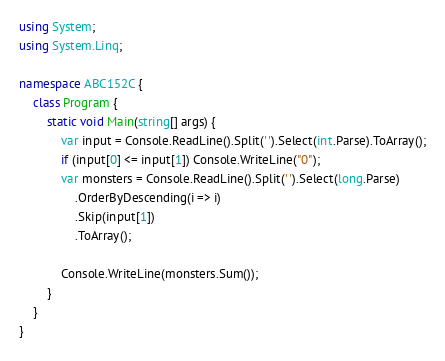<code> <loc_0><loc_0><loc_500><loc_500><_C#_>using System;
using System.Linq;

namespace ABC152C {
    class Program {
        static void Main(string[] args) {
            var input = Console.ReadLine().Split(' ').Select(int.Parse).ToArray();
            if (input[0] <= input[1]) Console.WriteLine("0");
            var monsters = Console.ReadLine().Split(' ').Select(long.Parse)
                .OrderByDescending(i => i)
                .Skip(input[1])
                .ToArray();

            Console.WriteLine(monsters.Sum());
        }
    }
}</code> 